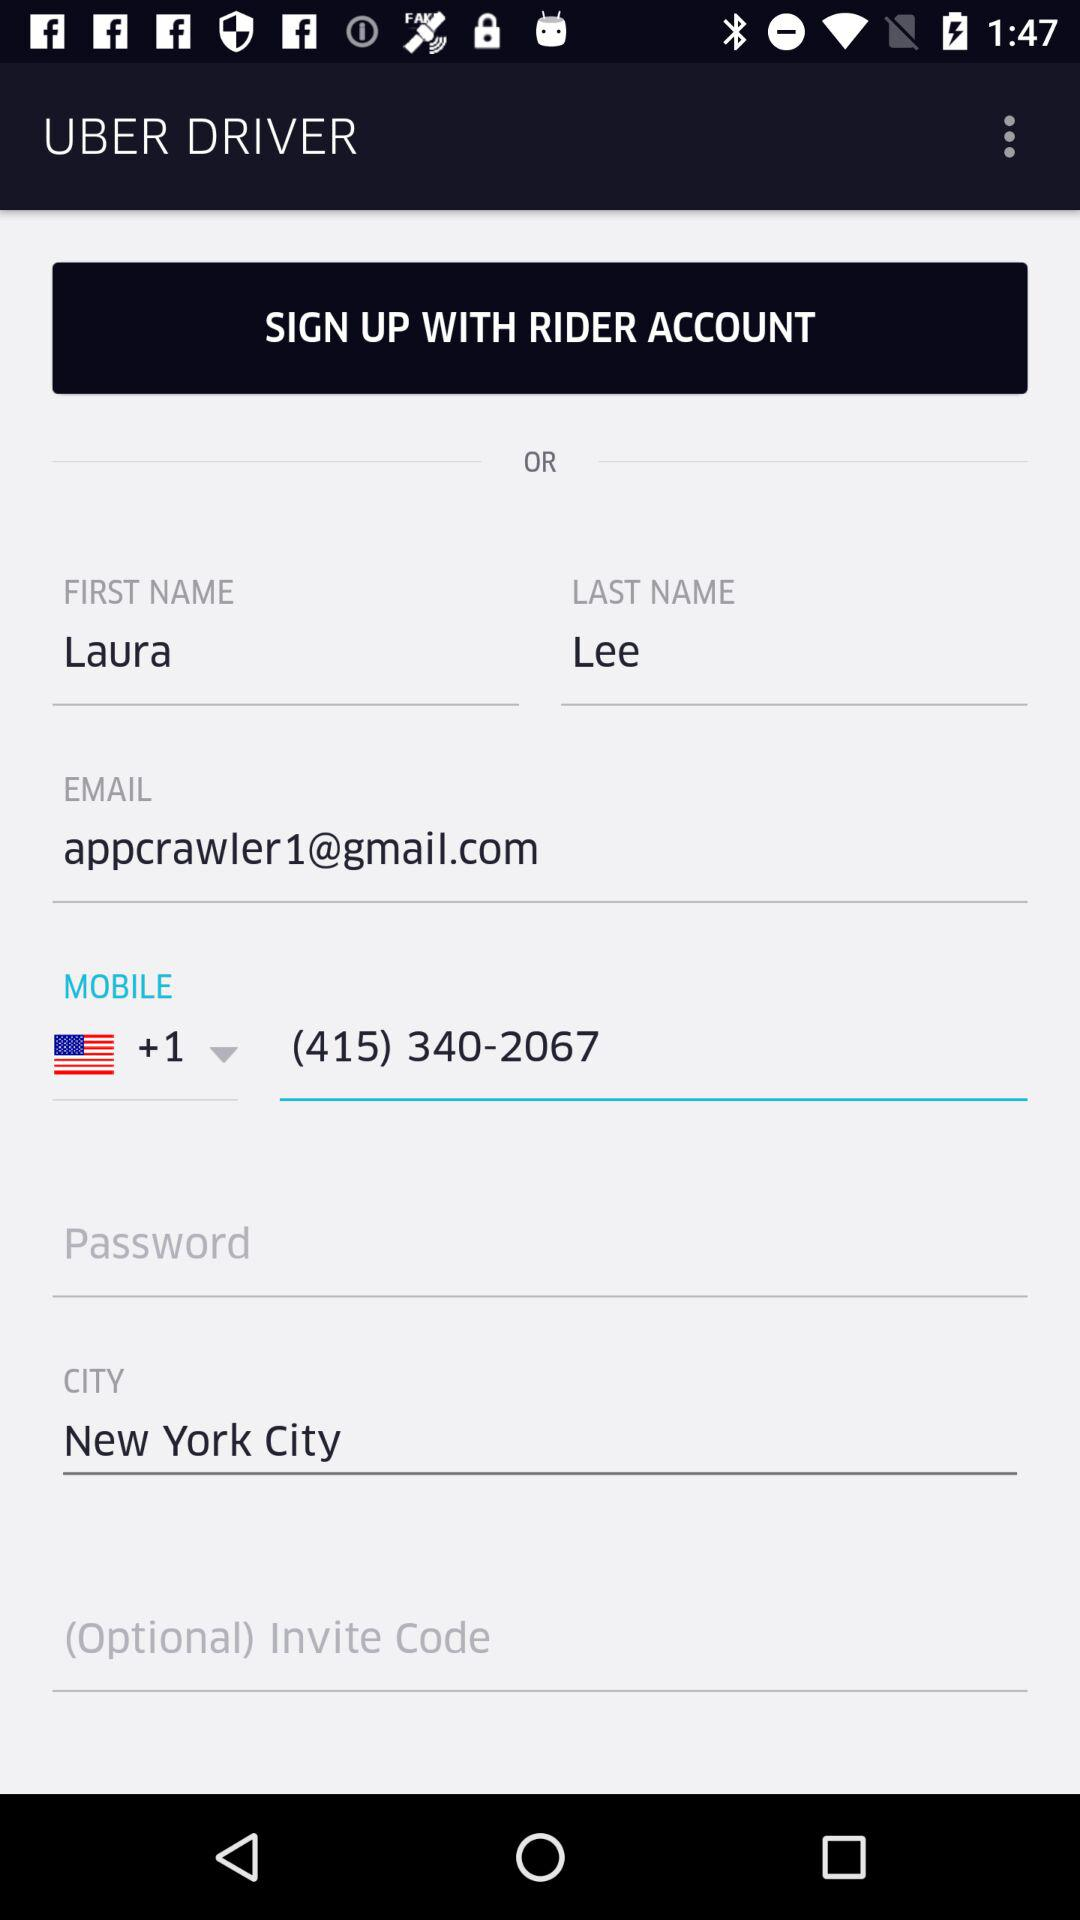What is the mobile number? The mobile number is +1 (415) 340-2067. 